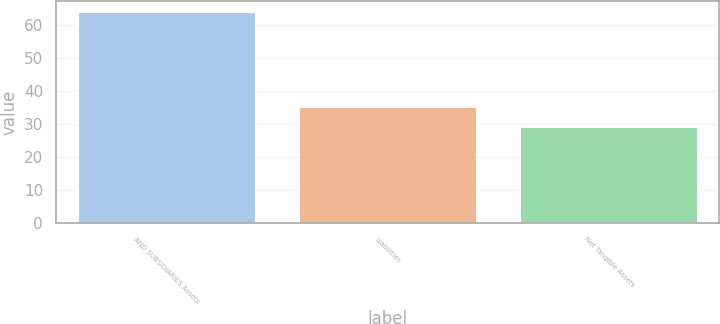Convert chart. <chart><loc_0><loc_0><loc_500><loc_500><bar_chart><fcel>AND SUBSIDIARIES Assets<fcel>Liabilities<fcel>Net Tangible Assets<nl><fcel>64<fcel>35<fcel>29<nl></chart> 